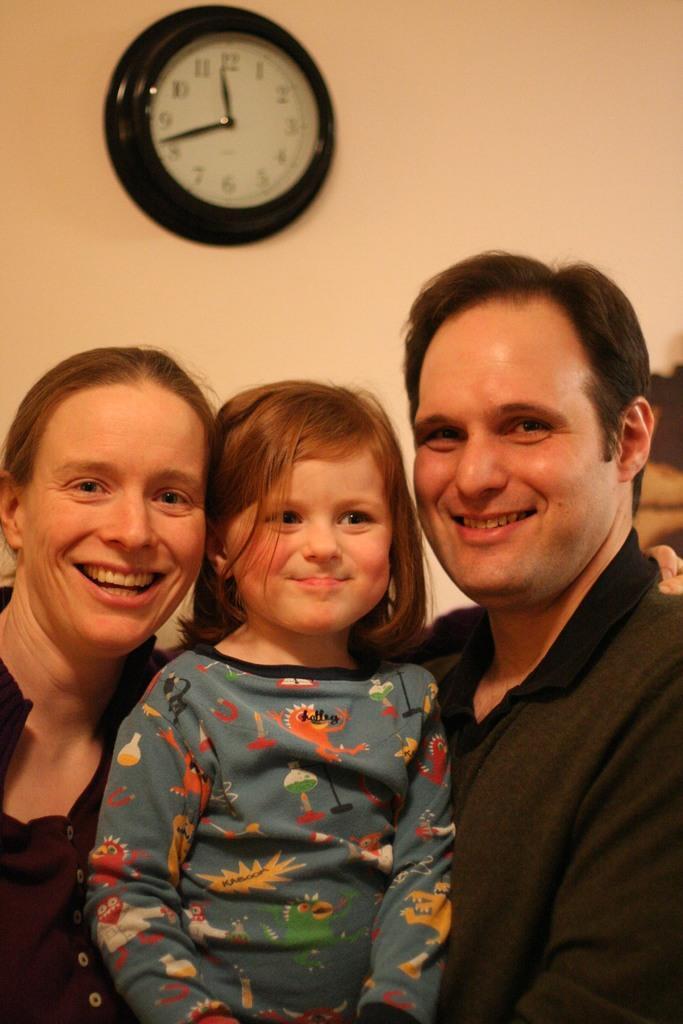Can you describe this image briefly? In this image we can see some people. In the background of the image we can see a clock on the wall. 